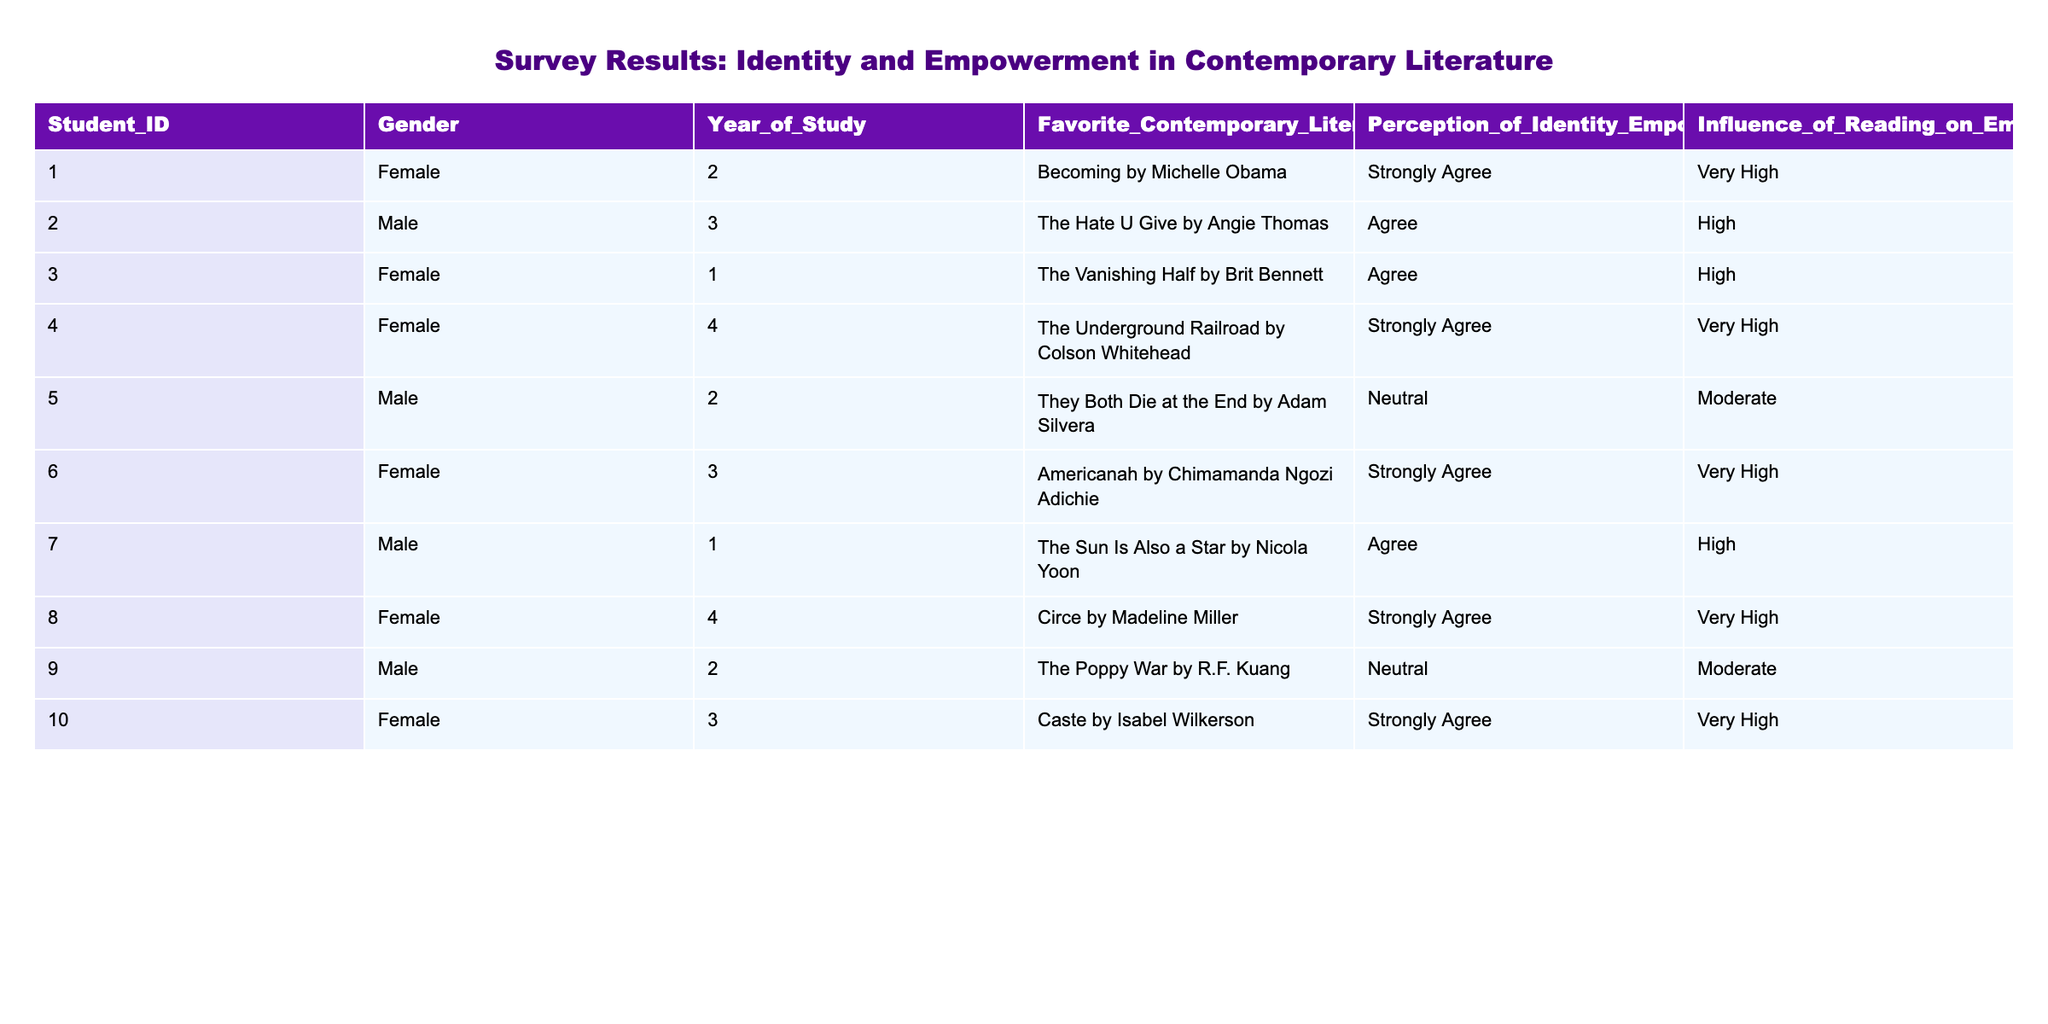What is the perception of identity empowerment for the student who prefers "Becoming by Michelle Obama"? The student's perception is mentioned in the table under the column "Perception_of_Identity_Empowerment". For Student_ID 1, the entry is "Strongly Agree".
Answer: Strongly Agree How many students agreed or strongly agreed with the perception of identity empowerment? To find the number of students who agreed or strongly agreed, we can count the entries under "Perception_of_Identity_Empowerment" that include "Agree" or "Strongly Agree". There are 6 such instances: Student_IDs 1, 2, 4, 6, 8, and 10.
Answer: 6 What is the average influence of reading on empowerment for males? We need to consider only the male students and their influence ratings. The male students' influence ratings are: High (1), Moderate (1), and High (1). Converting these ratings to numeric values: High = 3, Moderate = 2. The total is 3 + 2 + 3 = 8. There are 3 males, so the average is 8/3 = 2.67.
Answer: 2.67 Is there a strong perception of identity empowerment among female students? We look at the female students' perceptions, which are Strongly Agree (3) and Agree (2). To assess if it is strong, we check if the majority (more than half) express "Strongly Agree". Here, 3 out of 5 express a strong perception, which is a majority.
Answer: Yes Which contemporary literature work has the highest number of students expressing "Strongly Agree"? From the table, "Becoming by Michelle Obama", "The Underground Railroad by Colson Whitehead", "Americanah by Chimamanda Ngozi Adichie", "Circe by Madeline Miller", and "Caste by Isabel Wilkerson" all received "Strongly Agree" from one student each. The total count is equal across these works.
Answer: None, all tied What is the difference in the perception of empowerment between the genders? First, we identify the average perception ratings for each gender. For females, there are 5 entries: 3 Strongly Agree and 2 Agree, totaling a score (3*3 + 2*2)/5 = 2.6. For males, (1 Strongly Agree + 2 Agree + 1 Neutral) = (1*3 + 2*2 + 1*1) / 4 = 2.25. The difference is 2.6 - 2.25 = 0.35.
Answer: 0.35 How many students are in their final year, and what are their perceptions of identity empowerment? The final year students are identified by filtering "Year_of_Study". There are two in the final year (IDs 4 and 8), with perceptions "Strongly Agree" for both.
Answer: 2, Strongly Agree Are there more students who perceive reading as having a "Very High" influence or "High" influence on empowerment? We count students under "Influence_of_Reading_on_Empowerment". There are 4 students with "Very High" (1, 4, 6, 10) and 3 students with "High" (2, 3, 7). Thus, "Very High" has more students.
Answer: Very High What is the favorite literature work among the students with a neutral perception of identity empowerment? We filter the table for students with "Neutral" under the perception column. This corresponds to Student_IDs 5 and 9, with their favorite works being "They Both Die at the End by Adam Silvera" and "The Poppy War by R.F. Kuang."
Answer: They Both Die at the End by Adam Silvera, The Poppy War by R.F. Kuang 